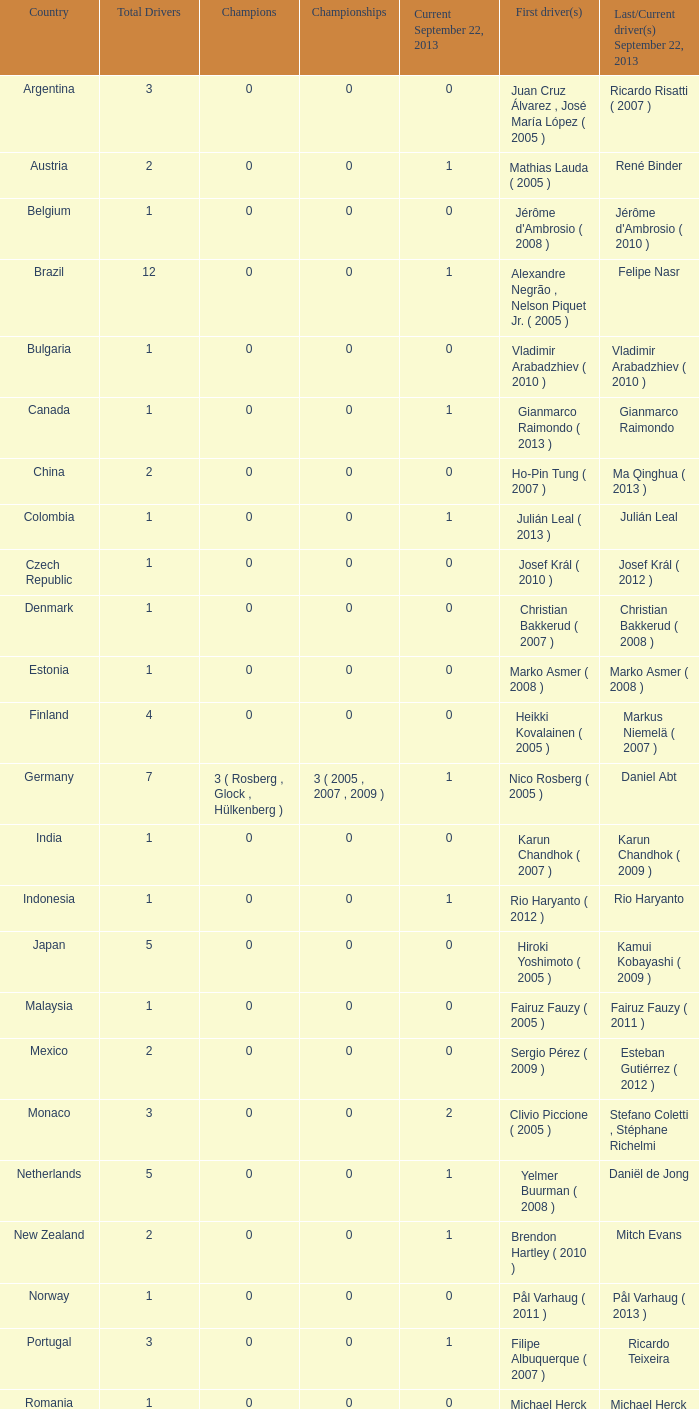In 2005, when hiroki yoshimoto was the first driver, how many champions were present? 0.0. 